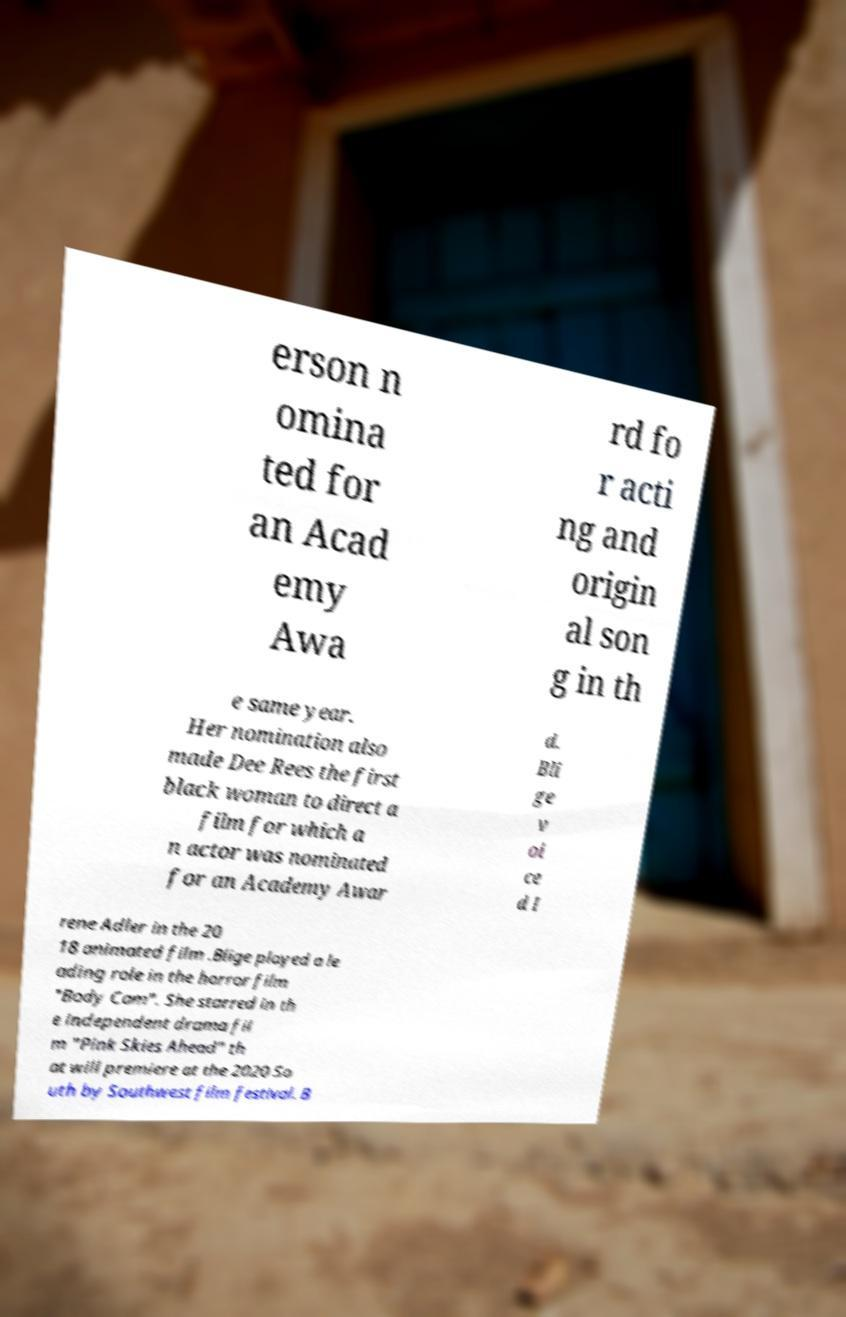For documentation purposes, I need the text within this image transcribed. Could you provide that? erson n omina ted for an Acad emy Awa rd fo r acti ng and origin al son g in th e same year. Her nomination also made Dee Rees the first black woman to direct a film for which a n actor was nominated for an Academy Awar d. Bli ge v oi ce d I rene Adler in the 20 18 animated film .Blige played a le ading role in the horror film "Body Cam". She starred in th e independent drama fil m "Pink Skies Ahead" th at will premiere at the 2020 So uth by Southwest film festival. B 